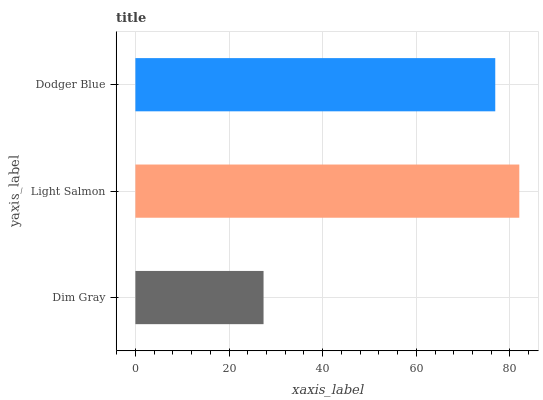Is Dim Gray the minimum?
Answer yes or no. Yes. Is Light Salmon the maximum?
Answer yes or no. Yes. Is Dodger Blue the minimum?
Answer yes or no. No. Is Dodger Blue the maximum?
Answer yes or no. No. Is Light Salmon greater than Dodger Blue?
Answer yes or no. Yes. Is Dodger Blue less than Light Salmon?
Answer yes or no. Yes. Is Dodger Blue greater than Light Salmon?
Answer yes or no. No. Is Light Salmon less than Dodger Blue?
Answer yes or no. No. Is Dodger Blue the high median?
Answer yes or no. Yes. Is Dodger Blue the low median?
Answer yes or no. Yes. Is Light Salmon the high median?
Answer yes or no. No. Is Dim Gray the low median?
Answer yes or no. No. 